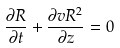<formula> <loc_0><loc_0><loc_500><loc_500>\frac { \partial R } { \partial t } + \frac { \partial v R ^ { 2 } } { \partial z } = 0</formula> 